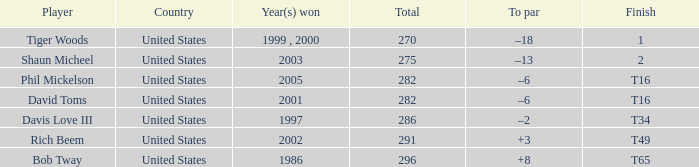Write the full table. {'header': ['Player', 'Country', 'Year(s) won', 'Total', 'To par', 'Finish'], 'rows': [['Tiger Woods', 'United States', '1999 , 2000', '270', '–18', '1'], ['Shaun Micheel', 'United States', '2003', '275', '–13', '2'], ['Phil Mickelson', 'United States', '2005', '282', '–6', 'T16'], ['David Toms', 'United States', '2001', '282', '–6', 'T16'], ['Davis Love III', 'United States', '1997', '286', '–2', 'T34'], ['Rich Beem', 'United States', '2002', '291', '+3', 'T49'], ['Bob Tway', 'United States', '1986', '296', '+8', 'T65']]} In which year(s) did the one who holds 291 victories succeed? 2002.0. 